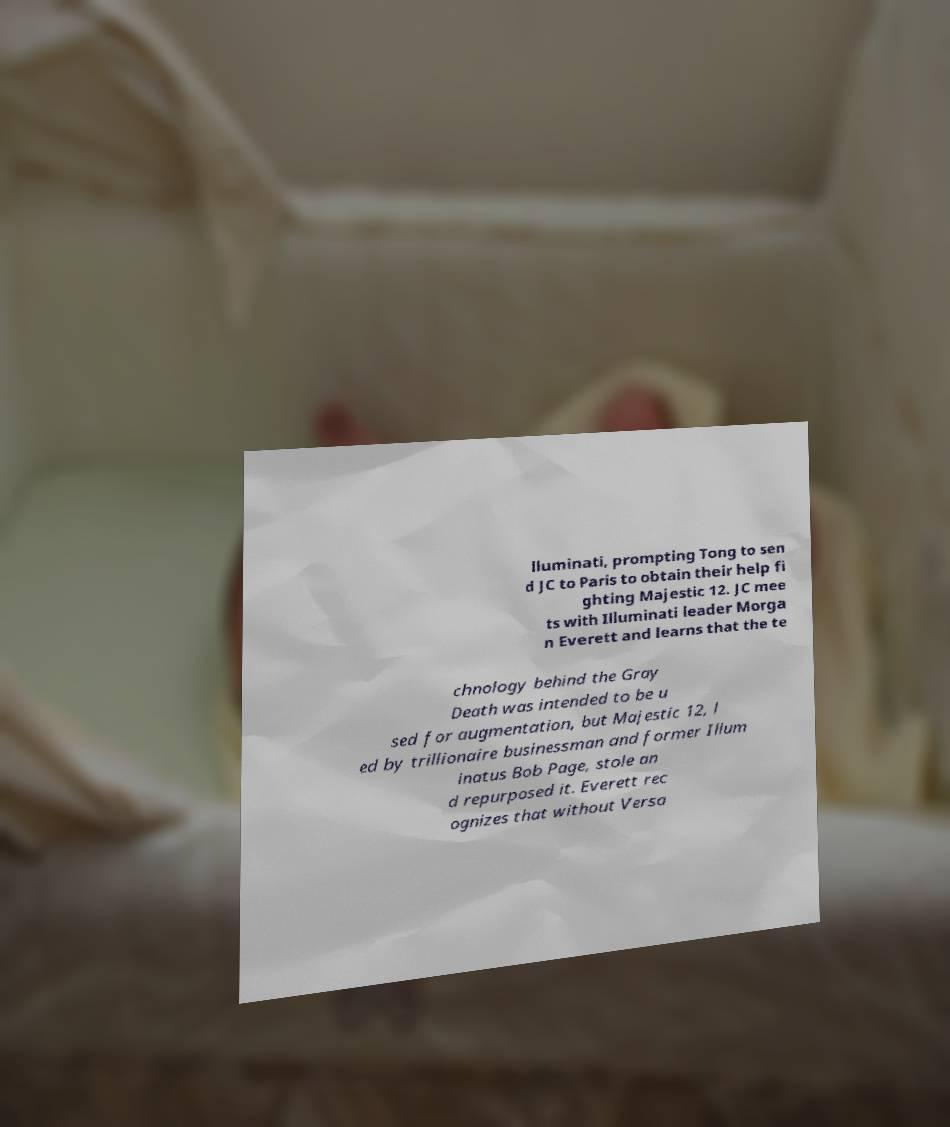Could you extract and type out the text from this image? lluminati, prompting Tong to sen d JC to Paris to obtain their help fi ghting Majestic 12. JC mee ts with Illuminati leader Morga n Everett and learns that the te chnology behind the Gray Death was intended to be u sed for augmentation, but Majestic 12, l ed by trillionaire businessman and former Illum inatus Bob Page, stole an d repurposed it. Everett rec ognizes that without Versa 